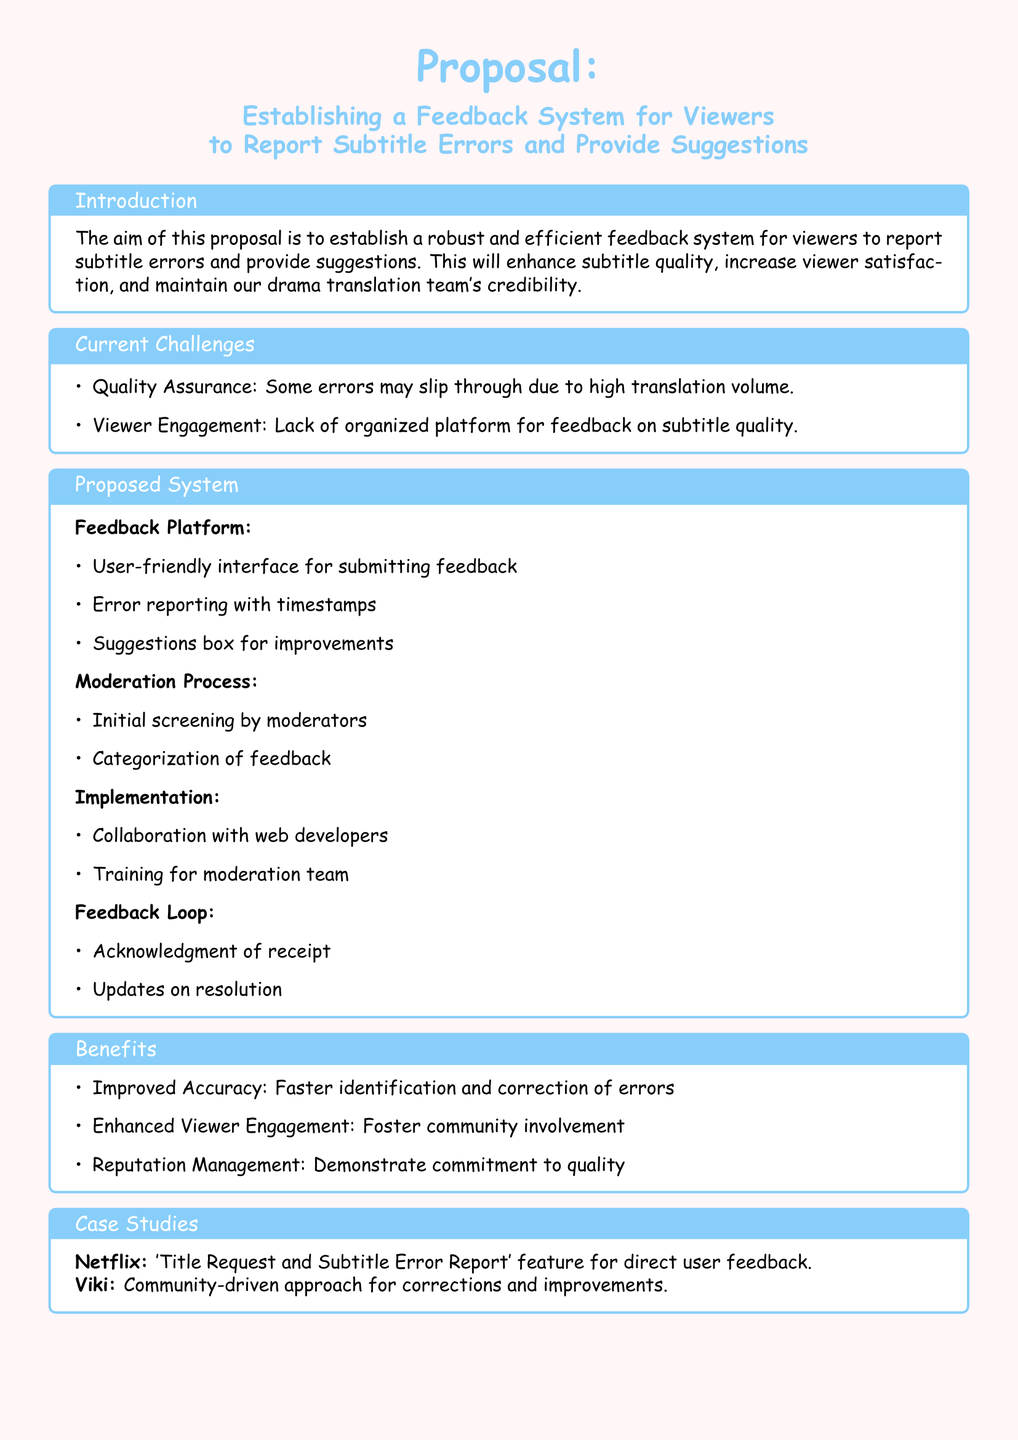What is the main focus of the proposal? The proposal focuses on establishing a feedback system for viewers to report subtitle errors and provide suggestions.
Answer: Establishing a feedback system for viewers What color is the page background? The document states the color of the page background is a light shade of pink.
Answer: Pink Name one current challenge mentioned in the proposal. The proposal lists "Quality Assurance" and "Viewer Engagement" as current challenges.
Answer: Quality Assurance What feature does the proposed feedback platform include? One of the features is a user-friendly interface for submitting feedback.
Answer: User-friendly interface Which company utilizes a subtitle error reporting feature? The proposal mentions that Netflix has a 'Title Request and Subtitle Error Report' feature for direct user feedback.
Answer: Netflix What is one benefit of implementing the feedback system? One benefit mentioned is "Improved Accuracy" due to faster identification and correction of errors.
Answer: Improved Accuracy Who will initially screen the feedback in the moderation process? The proposal states that moderators will perform the initial screening.
Answer: Moderators What does the feedback loop ensure? The feedback loop ensures acknowledgment of receipt and updates on resolution.
Answer: Acknowledgment of receipt 